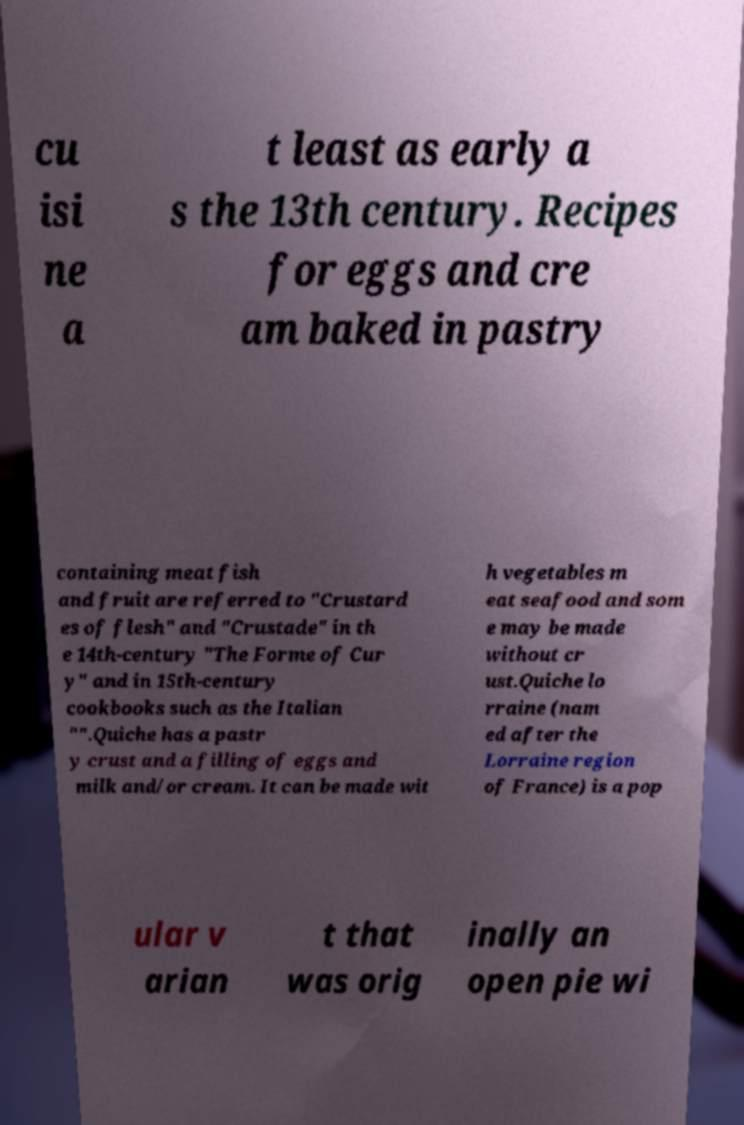Can you accurately transcribe the text from the provided image for me? cu isi ne a t least as early a s the 13th century. Recipes for eggs and cre am baked in pastry containing meat fish and fruit are referred to "Crustard es of flesh" and "Crustade" in th e 14th-century "The Forme of Cur y" and in 15th-century cookbooks such as the Italian "".Quiche has a pastr y crust and a filling of eggs and milk and/or cream. It can be made wit h vegetables m eat seafood and som e may be made without cr ust.Quiche lo rraine (nam ed after the Lorraine region of France) is a pop ular v arian t that was orig inally an open pie wi 